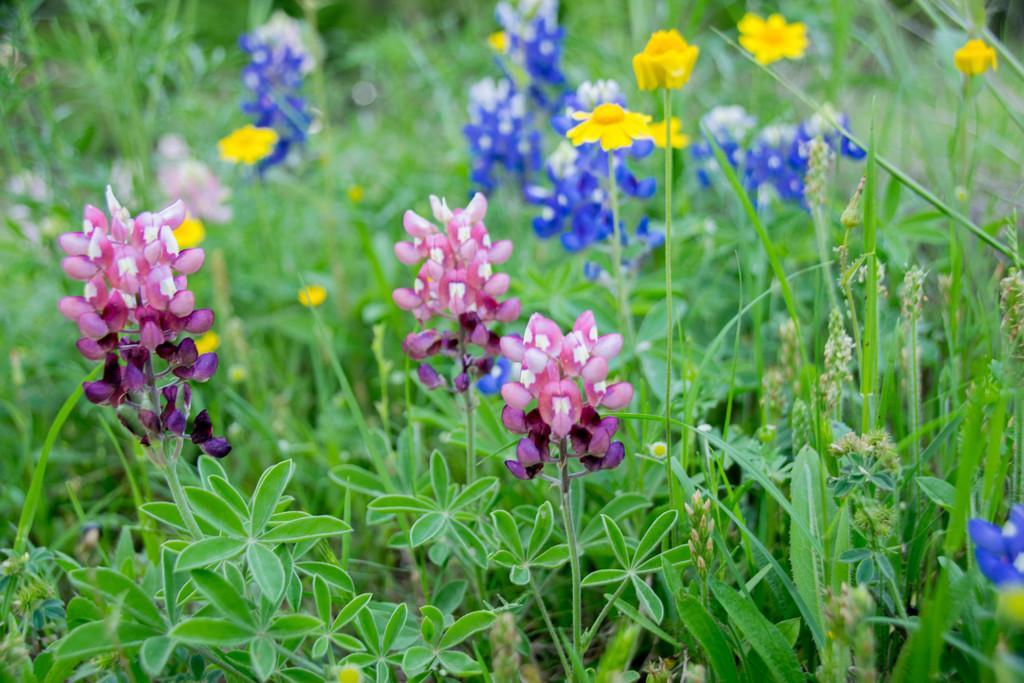Could you give a brief overview of what you see in this image? In this picture I see number of plants and I see few flowers which are of pink, yellow and blue in color. 